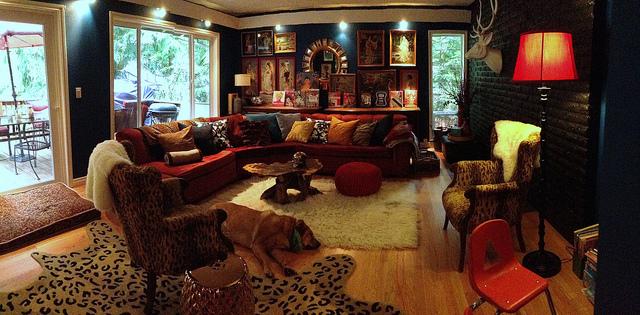Is there a fur on the floor?
Give a very brief answer. Yes. How many bookshelves are in this room?
Short answer required. 0. Is the dog a large breed?
Quick response, please. Yes. Is this place neat?
Quick response, please. Yes. 